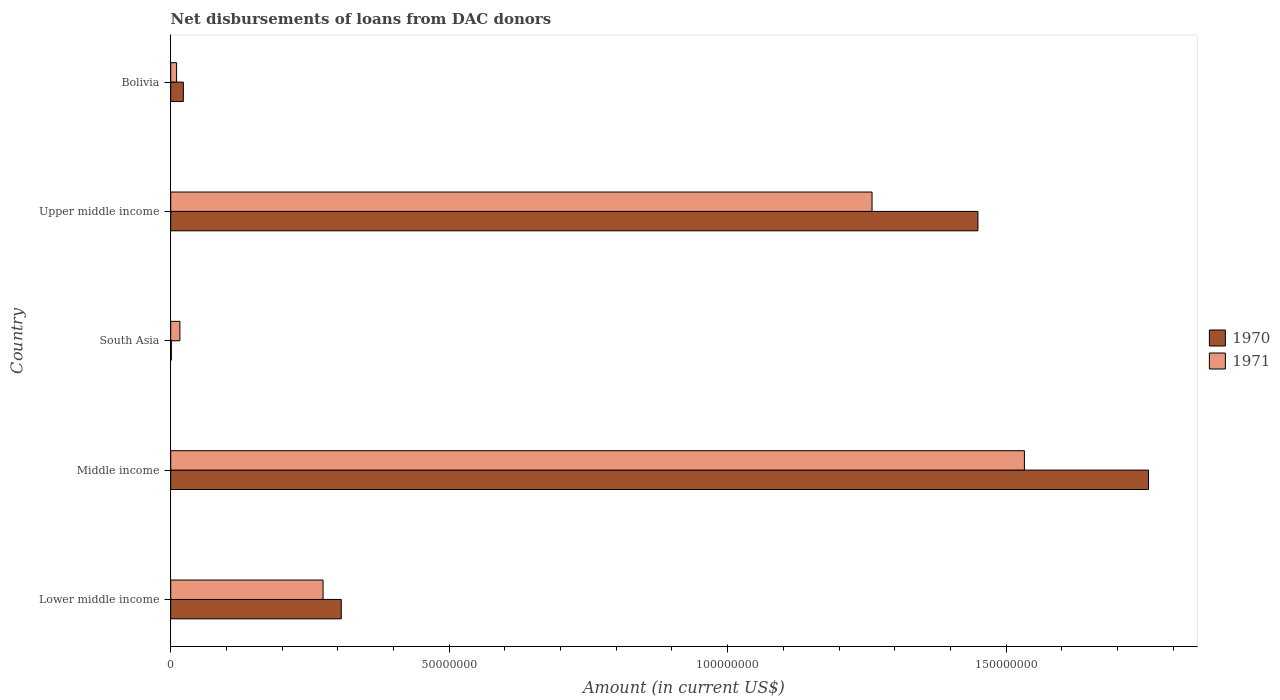How many different coloured bars are there?
Offer a very short reply. 2. Are the number of bars on each tick of the Y-axis equal?
Offer a very short reply. Yes. How many bars are there on the 4th tick from the top?
Provide a succinct answer. 2. What is the label of the 2nd group of bars from the top?
Your answer should be very brief. Upper middle income. What is the amount of loans disbursed in 1970 in South Asia?
Offer a terse response. 1.09e+05. Across all countries, what is the maximum amount of loans disbursed in 1970?
Offer a terse response. 1.76e+08. Across all countries, what is the minimum amount of loans disbursed in 1971?
Keep it short and to the point. 1.06e+06. In which country was the amount of loans disbursed in 1970 maximum?
Give a very brief answer. Middle income. What is the total amount of loans disbursed in 1970 in the graph?
Your answer should be compact. 3.53e+08. What is the difference between the amount of loans disbursed in 1970 in South Asia and that in Upper middle income?
Your answer should be compact. -1.45e+08. What is the difference between the amount of loans disbursed in 1971 in Lower middle income and the amount of loans disbursed in 1970 in Upper middle income?
Your response must be concise. -1.18e+08. What is the average amount of loans disbursed in 1971 per country?
Offer a terse response. 6.19e+07. What is the difference between the amount of loans disbursed in 1970 and amount of loans disbursed in 1971 in Lower middle income?
Provide a succinct answer. 3.27e+06. What is the ratio of the amount of loans disbursed in 1971 in Bolivia to that in Upper middle income?
Provide a short and direct response. 0.01. What is the difference between the highest and the second highest amount of loans disbursed in 1970?
Offer a terse response. 3.06e+07. What is the difference between the highest and the lowest amount of loans disbursed in 1971?
Offer a terse response. 1.52e+08. In how many countries, is the amount of loans disbursed in 1970 greater than the average amount of loans disbursed in 1970 taken over all countries?
Offer a terse response. 2. Is the sum of the amount of loans disbursed in 1970 in South Asia and Upper middle income greater than the maximum amount of loans disbursed in 1971 across all countries?
Your answer should be compact. No. What does the 2nd bar from the top in South Asia represents?
Provide a succinct answer. 1970. How many countries are there in the graph?
Offer a very short reply. 5. Are the values on the major ticks of X-axis written in scientific E-notation?
Provide a succinct answer. No. Does the graph contain any zero values?
Give a very brief answer. No. Does the graph contain grids?
Ensure brevity in your answer.  No. Where does the legend appear in the graph?
Offer a terse response. Center right. How are the legend labels stacked?
Your answer should be compact. Vertical. What is the title of the graph?
Your answer should be compact. Net disbursements of loans from DAC donors. What is the label or title of the Y-axis?
Make the answer very short. Country. What is the Amount (in current US$) in 1970 in Lower middle income?
Your answer should be compact. 3.06e+07. What is the Amount (in current US$) in 1971 in Lower middle income?
Make the answer very short. 2.74e+07. What is the Amount (in current US$) of 1970 in Middle income?
Make the answer very short. 1.76e+08. What is the Amount (in current US$) in 1971 in Middle income?
Offer a very short reply. 1.53e+08. What is the Amount (in current US$) in 1970 in South Asia?
Provide a succinct answer. 1.09e+05. What is the Amount (in current US$) in 1971 in South Asia?
Provide a short and direct response. 1.65e+06. What is the Amount (in current US$) of 1970 in Upper middle income?
Your answer should be compact. 1.45e+08. What is the Amount (in current US$) of 1971 in Upper middle income?
Offer a very short reply. 1.26e+08. What is the Amount (in current US$) in 1970 in Bolivia?
Provide a short and direct response. 2.27e+06. What is the Amount (in current US$) in 1971 in Bolivia?
Provide a succinct answer. 1.06e+06. Across all countries, what is the maximum Amount (in current US$) in 1970?
Provide a succinct answer. 1.76e+08. Across all countries, what is the maximum Amount (in current US$) of 1971?
Ensure brevity in your answer.  1.53e+08. Across all countries, what is the minimum Amount (in current US$) of 1970?
Your answer should be very brief. 1.09e+05. Across all countries, what is the minimum Amount (in current US$) in 1971?
Ensure brevity in your answer.  1.06e+06. What is the total Amount (in current US$) of 1970 in the graph?
Provide a short and direct response. 3.53e+08. What is the total Amount (in current US$) in 1971 in the graph?
Your response must be concise. 3.09e+08. What is the difference between the Amount (in current US$) of 1970 in Lower middle income and that in Middle income?
Offer a very short reply. -1.45e+08. What is the difference between the Amount (in current US$) in 1971 in Lower middle income and that in Middle income?
Offer a terse response. -1.26e+08. What is the difference between the Amount (in current US$) in 1970 in Lower middle income and that in South Asia?
Keep it short and to the point. 3.05e+07. What is the difference between the Amount (in current US$) of 1971 in Lower middle income and that in South Asia?
Make the answer very short. 2.57e+07. What is the difference between the Amount (in current US$) of 1970 in Lower middle income and that in Upper middle income?
Your answer should be very brief. -1.14e+08. What is the difference between the Amount (in current US$) in 1971 in Lower middle income and that in Upper middle income?
Your response must be concise. -9.86e+07. What is the difference between the Amount (in current US$) in 1970 in Lower middle income and that in Bolivia?
Keep it short and to the point. 2.84e+07. What is the difference between the Amount (in current US$) in 1971 in Lower middle income and that in Bolivia?
Provide a short and direct response. 2.63e+07. What is the difference between the Amount (in current US$) in 1970 in Middle income and that in South Asia?
Provide a short and direct response. 1.75e+08. What is the difference between the Amount (in current US$) of 1971 in Middle income and that in South Asia?
Your response must be concise. 1.52e+08. What is the difference between the Amount (in current US$) of 1970 in Middle income and that in Upper middle income?
Offer a very short reply. 3.06e+07. What is the difference between the Amount (in current US$) in 1971 in Middle income and that in Upper middle income?
Give a very brief answer. 2.74e+07. What is the difference between the Amount (in current US$) of 1970 in Middle income and that in Bolivia?
Keep it short and to the point. 1.73e+08. What is the difference between the Amount (in current US$) in 1971 in Middle income and that in Bolivia?
Offer a very short reply. 1.52e+08. What is the difference between the Amount (in current US$) in 1970 in South Asia and that in Upper middle income?
Make the answer very short. -1.45e+08. What is the difference between the Amount (in current US$) of 1971 in South Asia and that in Upper middle income?
Make the answer very short. -1.24e+08. What is the difference between the Amount (in current US$) of 1970 in South Asia and that in Bolivia?
Your answer should be very brief. -2.16e+06. What is the difference between the Amount (in current US$) of 1971 in South Asia and that in Bolivia?
Your answer should be very brief. 5.92e+05. What is the difference between the Amount (in current US$) of 1970 in Upper middle income and that in Bolivia?
Your answer should be compact. 1.43e+08. What is the difference between the Amount (in current US$) of 1971 in Upper middle income and that in Bolivia?
Your answer should be compact. 1.25e+08. What is the difference between the Amount (in current US$) in 1970 in Lower middle income and the Amount (in current US$) in 1971 in Middle income?
Your answer should be compact. -1.23e+08. What is the difference between the Amount (in current US$) in 1970 in Lower middle income and the Amount (in current US$) in 1971 in South Asia?
Provide a short and direct response. 2.90e+07. What is the difference between the Amount (in current US$) in 1970 in Lower middle income and the Amount (in current US$) in 1971 in Upper middle income?
Offer a terse response. -9.53e+07. What is the difference between the Amount (in current US$) in 1970 in Lower middle income and the Amount (in current US$) in 1971 in Bolivia?
Give a very brief answer. 2.96e+07. What is the difference between the Amount (in current US$) in 1970 in Middle income and the Amount (in current US$) in 1971 in South Asia?
Provide a short and direct response. 1.74e+08. What is the difference between the Amount (in current US$) of 1970 in Middle income and the Amount (in current US$) of 1971 in Upper middle income?
Keep it short and to the point. 4.96e+07. What is the difference between the Amount (in current US$) in 1970 in Middle income and the Amount (in current US$) in 1971 in Bolivia?
Provide a succinct answer. 1.74e+08. What is the difference between the Amount (in current US$) of 1970 in South Asia and the Amount (in current US$) of 1971 in Upper middle income?
Your answer should be compact. -1.26e+08. What is the difference between the Amount (in current US$) in 1970 in South Asia and the Amount (in current US$) in 1971 in Bolivia?
Give a very brief answer. -9.49e+05. What is the difference between the Amount (in current US$) of 1970 in Upper middle income and the Amount (in current US$) of 1971 in Bolivia?
Ensure brevity in your answer.  1.44e+08. What is the average Amount (in current US$) in 1970 per country?
Offer a very short reply. 7.07e+07. What is the average Amount (in current US$) in 1971 per country?
Keep it short and to the point. 6.19e+07. What is the difference between the Amount (in current US$) in 1970 and Amount (in current US$) in 1971 in Lower middle income?
Your answer should be compact. 3.27e+06. What is the difference between the Amount (in current US$) in 1970 and Amount (in current US$) in 1971 in Middle income?
Keep it short and to the point. 2.23e+07. What is the difference between the Amount (in current US$) of 1970 and Amount (in current US$) of 1971 in South Asia?
Keep it short and to the point. -1.54e+06. What is the difference between the Amount (in current US$) of 1970 and Amount (in current US$) of 1971 in Upper middle income?
Provide a short and direct response. 1.90e+07. What is the difference between the Amount (in current US$) of 1970 and Amount (in current US$) of 1971 in Bolivia?
Provide a succinct answer. 1.21e+06. What is the ratio of the Amount (in current US$) of 1970 in Lower middle income to that in Middle income?
Offer a terse response. 0.17. What is the ratio of the Amount (in current US$) of 1971 in Lower middle income to that in Middle income?
Provide a short and direct response. 0.18. What is the ratio of the Amount (in current US$) of 1970 in Lower middle income to that in South Asia?
Your answer should be very brief. 280.94. What is the ratio of the Amount (in current US$) in 1971 in Lower middle income to that in South Asia?
Ensure brevity in your answer.  16.58. What is the ratio of the Amount (in current US$) of 1970 in Lower middle income to that in Upper middle income?
Your response must be concise. 0.21. What is the ratio of the Amount (in current US$) of 1971 in Lower middle income to that in Upper middle income?
Your answer should be very brief. 0.22. What is the ratio of the Amount (in current US$) in 1970 in Lower middle income to that in Bolivia?
Provide a succinct answer. 13.49. What is the ratio of the Amount (in current US$) of 1971 in Lower middle income to that in Bolivia?
Offer a very short reply. 25.85. What is the ratio of the Amount (in current US$) of 1970 in Middle income to that in South Asia?
Provide a succinct answer. 1610.58. What is the ratio of the Amount (in current US$) in 1971 in Middle income to that in South Asia?
Your answer should be very brief. 92.89. What is the ratio of the Amount (in current US$) in 1970 in Middle income to that in Upper middle income?
Your response must be concise. 1.21. What is the ratio of the Amount (in current US$) of 1971 in Middle income to that in Upper middle income?
Give a very brief answer. 1.22. What is the ratio of the Amount (in current US$) in 1970 in Middle income to that in Bolivia?
Your answer should be very brief. 77.34. What is the ratio of the Amount (in current US$) of 1971 in Middle income to that in Bolivia?
Keep it short and to the point. 144.87. What is the ratio of the Amount (in current US$) in 1970 in South Asia to that in Upper middle income?
Your answer should be compact. 0. What is the ratio of the Amount (in current US$) of 1971 in South Asia to that in Upper middle income?
Ensure brevity in your answer.  0.01. What is the ratio of the Amount (in current US$) of 1970 in South Asia to that in Bolivia?
Keep it short and to the point. 0.05. What is the ratio of the Amount (in current US$) in 1971 in South Asia to that in Bolivia?
Keep it short and to the point. 1.56. What is the ratio of the Amount (in current US$) of 1970 in Upper middle income to that in Bolivia?
Your answer should be compact. 63.85. What is the ratio of the Amount (in current US$) of 1971 in Upper middle income to that in Bolivia?
Provide a succinct answer. 119.02. What is the difference between the highest and the second highest Amount (in current US$) of 1970?
Ensure brevity in your answer.  3.06e+07. What is the difference between the highest and the second highest Amount (in current US$) in 1971?
Offer a terse response. 2.74e+07. What is the difference between the highest and the lowest Amount (in current US$) of 1970?
Offer a terse response. 1.75e+08. What is the difference between the highest and the lowest Amount (in current US$) of 1971?
Your response must be concise. 1.52e+08. 